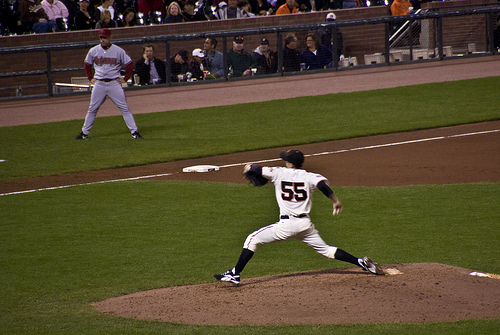Are there either any shoppers or umpires? No, the image does not show any shoppers or umpires. 